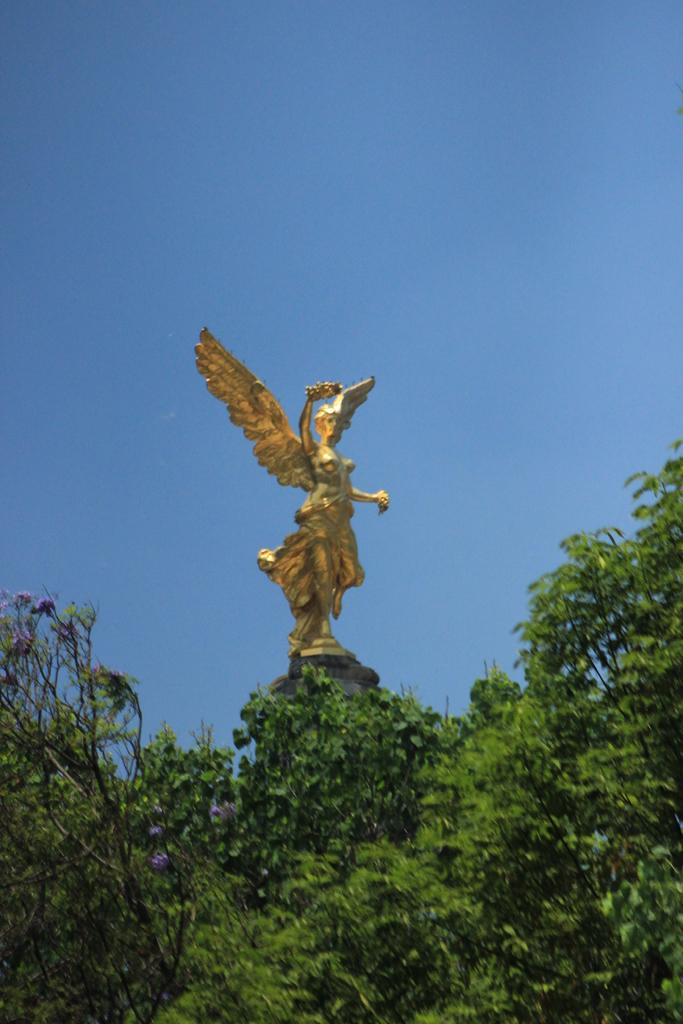What type of vegetation can be seen in the image? There are trees in the image. What is the main subject in the middle of the image? There is a statue in the middle of the image. What can be seen in the background of the image? The sky is visible in the background of the image. What song is being sung by the chickens in the image? There are no chickens present in the image, so there is no song being sung. How much dirt is visible around the statue in the image? There is no dirt visible around the statue in the image; it is standing on a surface that is not specified. 